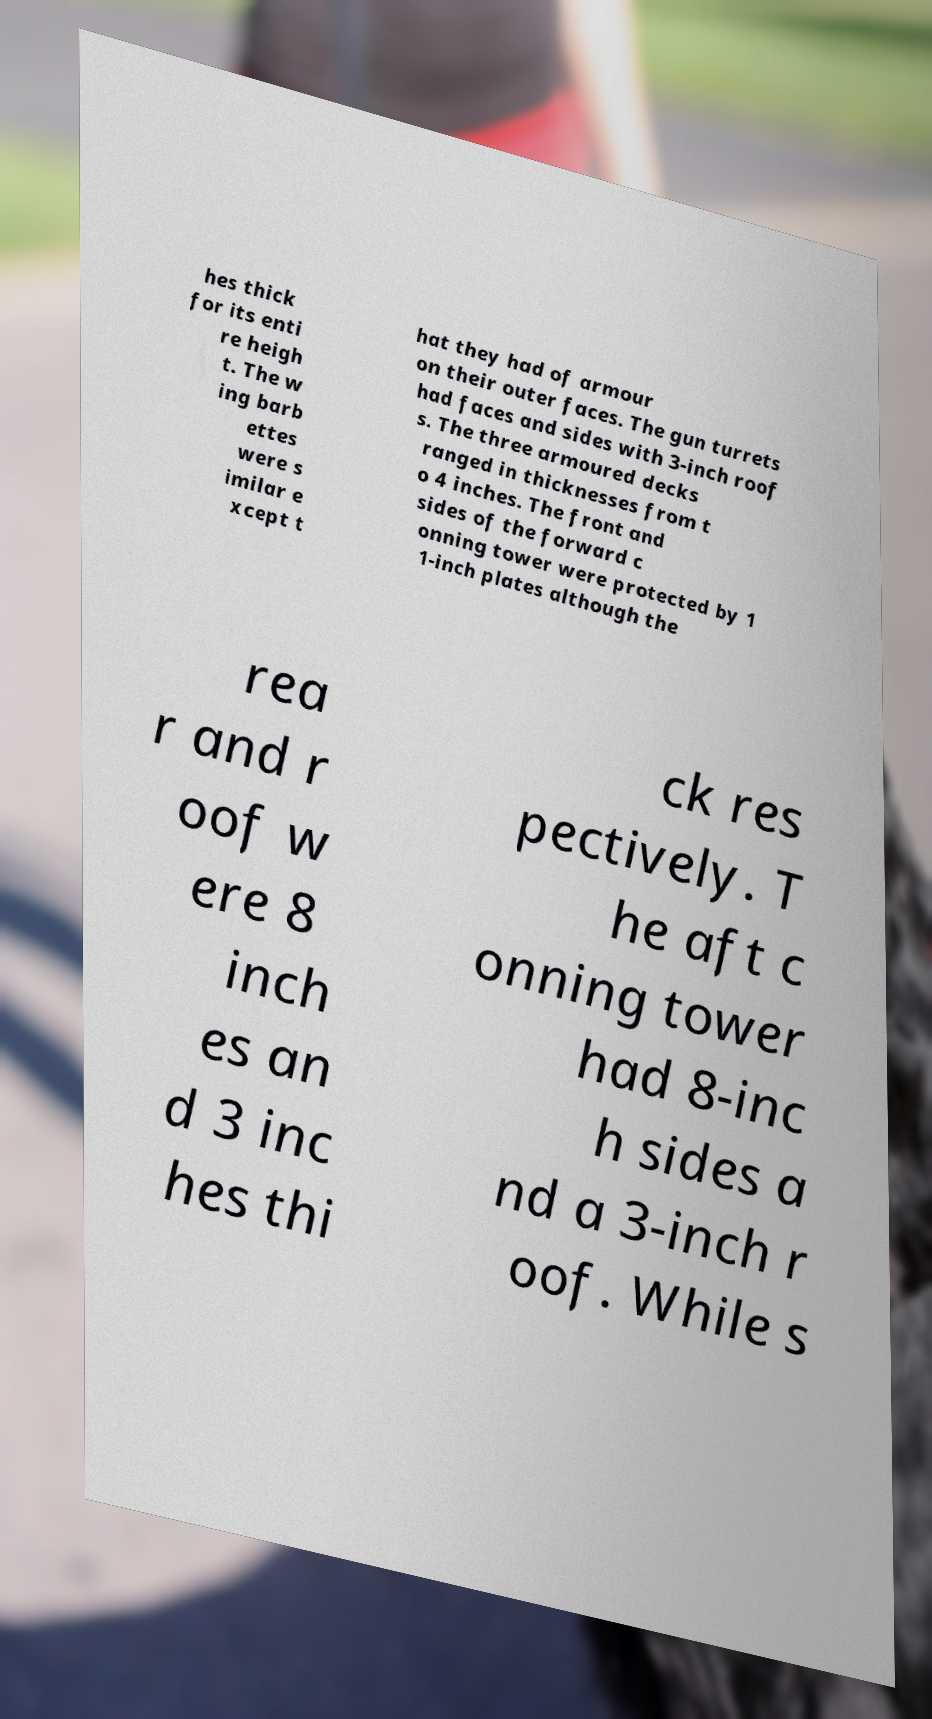What messages or text are displayed in this image? I need them in a readable, typed format. hes thick for its enti re heigh t. The w ing barb ettes were s imilar e xcept t hat they had of armour on their outer faces. The gun turrets had faces and sides with 3-inch roof s. The three armoured decks ranged in thicknesses from t o 4 inches. The front and sides of the forward c onning tower were protected by 1 1-inch plates although the rea r and r oof w ere 8 inch es an d 3 inc hes thi ck res pectively. T he aft c onning tower had 8-inc h sides a nd a 3-inch r oof. While s 